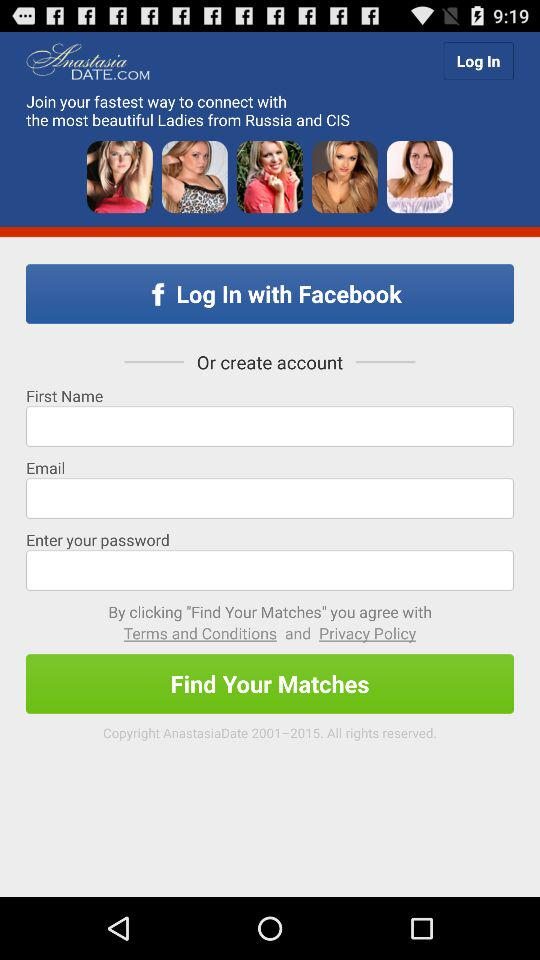Which account will continue?
When the provided information is insufficient, respond with <no answer>. <no answer> 